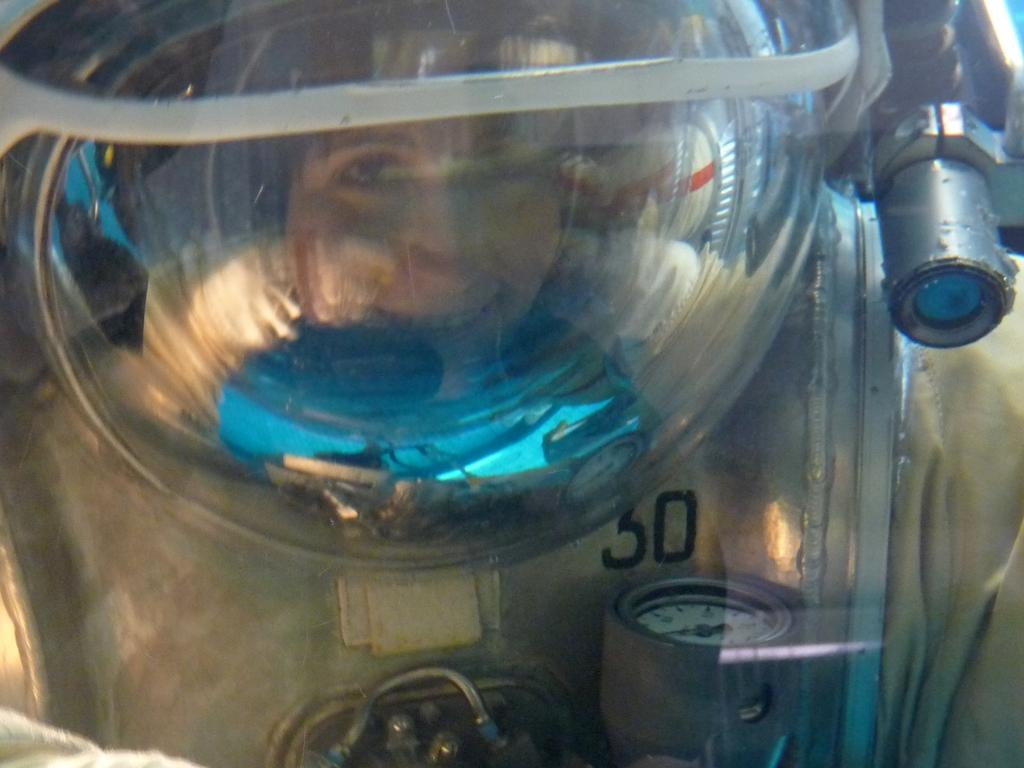What is the main subject in the foreground of the image? There is a person in the foreground of the image. What is the person wearing? The person is wearing a helmet. What is the person's facial expression? The person is smiling. What else can be seen in the foreground of the image? There are other objects visible in the foreground. Can you see a robin perched on the person's shoulder in the image? No, there is no robin present in the image. What type of furniture is visible in the foreground of the image? There is no furniture visible in the foreground of the image. 